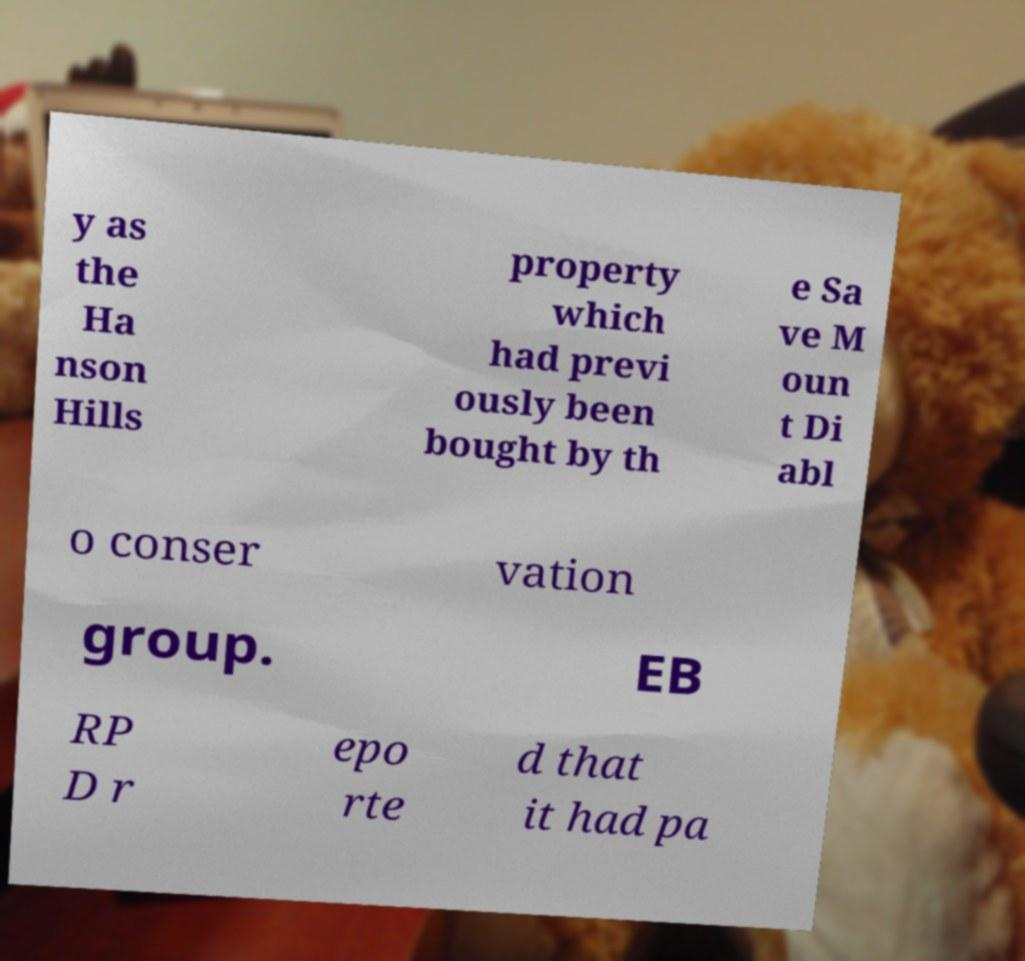Can you accurately transcribe the text from the provided image for me? y as the Ha nson Hills property which had previ ously been bought by th e Sa ve M oun t Di abl o conser vation group. EB RP D r epo rte d that it had pa 